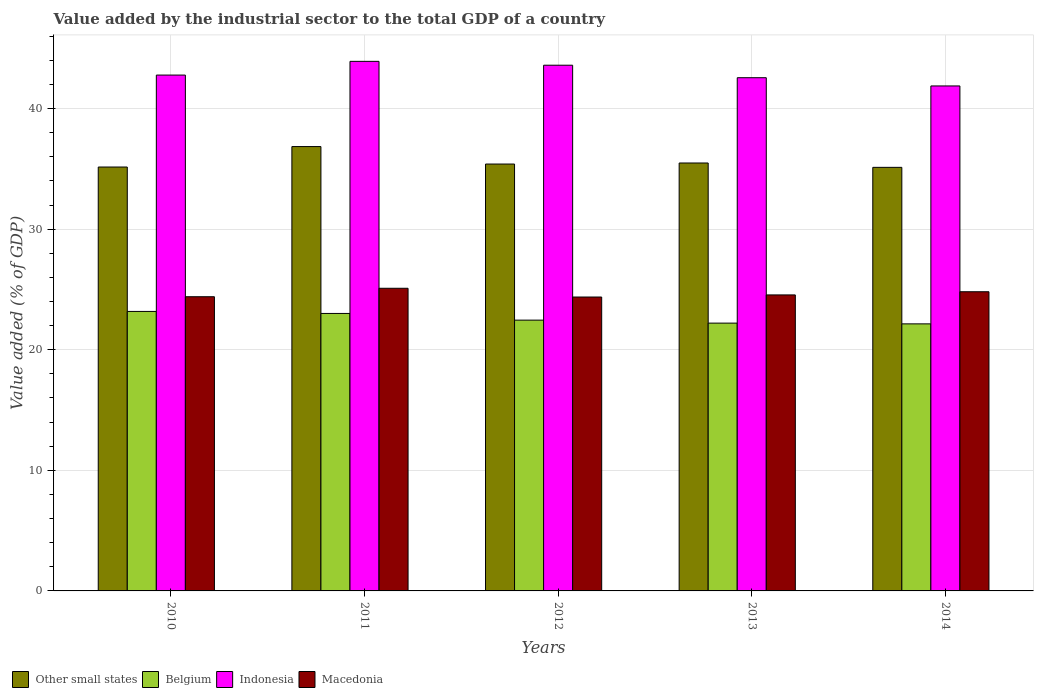How many groups of bars are there?
Offer a very short reply. 5. Are the number of bars per tick equal to the number of legend labels?
Offer a very short reply. Yes. How many bars are there on the 4th tick from the right?
Your response must be concise. 4. What is the value added by the industrial sector to the total GDP in Other small states in 2013?
Provide a short and direct response. 35.49. Across all years, what is the maximum value added by the industrial sector to the total GDP in Indonesia?
Give a very brief answer. 43.91. Across all years, what is the minimum value added by the industrial sector to the total GDP in Indonesia?
Keep it short and to the point. 41.87. What is the total value added by the industrial sector to the total GDP in Macedonia in the graph?
Your answer should be very brief. 123.22. What is the difference between the value added by the industrial sector to the total GDP in Macedonia in 2012 and that in 2013?
Offer a terse response. -0.17. What is the difference between the value added by the industrial sector to the total GDP in Other small states in 2011 and the value added by the industrial sector to the total GDP in Belgium in 2014?
Give a very brief answer. 14.7. What is the average value added by the industrial sector to the total GDP in Other small states per year?
Provide a succinct answer. 35.6. In the year 2013, what is the difference between the value added by the industrial sector to the total GDP in Macedonia and value added by the industrial sector to the total GDP in Indonesia?
Ensure brevity in your answer.  -18.01. What is the ratio of the value added by the industrial sector to the total GDP in Other small states in 2012 to that in 2014?
Your answer should be compact. 1.01. What is the difference between the highest and the second highest value added by the industrial sector to the total GDP in Other small states?
Keep it short and to the point. 1.36. What is the difference between the highest and the lowest value added by the industrial sector to the total GDP in Macedonia?
Offer a terse response. 0.72. Is it the case that in every year, the sum of the value added by the industrial sector to the total GDP in Indonesia and value added by the industrial sector to the total GDP in Other small states is greater than the sum of value added by the industrial sector to the total GDP in Belgium and value added by the industrial sector to the total GDP in Macedonia?
Make the answer very short. No. What does the 4th bar from the left in 2011 represents?
Provide a short and direct response. Macedonia. Is it the case that in every year, the sum of the value added by the industrial sector to the total GDP in Belgium and value added by the industrial sector to the total GDP in Macedonia is greater than the value added by the industrial sector to the total GDP in Other small states?
Your response must be concise. Yes. Are the values on the major ticks of Y-axis written in scientific E-notation?
Your answer should be very brief. No. Does the graph contain any zero values?
Give a very brief answer. No. Does the graph contain grids?
Offer a very short reply. Yes. Where does the legend appear in the graph?
Keep it short and to the point. Bottom left. How many legend labels are there?
Give a very brief answer. 4. What is the title of the graph?
Your answer should be very brief. Value added by the industrial sector to the total GDP of a country. Does "Mauritius" appear as one of the legend labels in the graph?
Keep it short and to the point. No. What is the label or title of the Y-axis?
Your answer should be very brief. Value added (% of GDP). What is the Value added (% of GDP) in Other small states in 2010?
Ensure brevity in your answer.  35.15. What is the Value added (% of GDP) in Belgium in 2010?
Provide a short and direct response. 23.18. What is the Value added (% of GDP) in Indonesia in 2010?
Your response must be concise. 42.78. What is the Value added (% of GDP) of Macedonia in 2010?
Provide a succinct answer. 24.4. What is the Value added (% of GDP) of Other small states in 2011?
Your response must be concise. 36.85. What is the Value added (% of GDP) of Belgium in 2011?
Offer a terse response. 23.01. What is the Value added (% of GDP) of Indonesia in 2011?
Your answer should be compact. 43.91. What is the Value added (% of GDP) of Macedonia in 2011?
Give a very brief answer. 25.1. What is the Value added (% of GDP) in Other small states in 2012?
Ensure brevity in your answer.  35.4. What is the Value added (% of GDP) in Belgium in 2012?
Keep it short and to the point. 22.45. What is the Value added (% of GDP) in Indonesia in 2012?
Your response must be concise. 43.59. What is the Value added (% of GDP) of Macedonia in 2012?
Your response must be concise. 24.37. What is the Value added (% of GDP) of Other small states in 2013?
Keep it short and to the point. 35.49. What is the Value added (% of GDP) in Belgium in 2013?
Your response must be concise. 22.21. What is the Value added (% of GDP) of Indonesia in 2013?
Make the answer very short. 42.56. What is the Value added (% of GDP) of Macedonia in 2013?
Make the answer very short. 24.55. What is the Value added (% of GDP) in Other small states in 2014?
Offer a very short reply. 35.12. What is the Value added (% of GDP) in Belgium in 2014?
Your answer should be very brief. 22.15. What is the Value added (% of GDP) in Indonesia in 2014?
Your answer should be compact. 41.87. What is the Value added (% of GDP) in Macedonia in 2014?
Provide a succinct answer. 24.81. Across all years, what is the maximum Value added (% of GDP) in Other small states?
Make the answer very short. 36.85. Across all years, what is the maximum Value added (% of GDP) in Belgium?
Offer a terse response. 23.18. Across all years, what is the maximum Value added (% of GDP) of Indonesia?
Provide a short and direct response. 43.91. Across all years, what is the maximum Value added (% of GDP) in Macedonia?
Ensure brevity in your answer.  25.1. Across all years, what is the minimum Value added (% of GDP) of Other small states?
Your answer should be very brief. 35.12. Across all years, what is the minimum Value added (% of GDP) in Belgium?
Keep it short and to the point. 22.15. Across all years, what is the minimum Value added (% of GDP) of Indonesia?
Your answer should be very brief. 41.87. Across all years, what is the minimum Value added (% of GDP) in Macedonia?
Provide a succinct answer. 24.37. What is the total Value added (% of GDP) in Other small states in the graph?
Offer a very short reply. 178.01. What is the total Value added (% of GDP) in Belgium in the graph?
Provide a short and direct response. 112.99. What is the total Value added (% of GDP) of Indonesia in the graph?
Make the answer very short. 214.71. What is the total Value added (% of GDP) of Macedonia in the graph?
Make the answer very short. 123.22. What is the difference between the Value added (% of GDP) in Other small states in 2010 and that in 2011?
Provide a succinct answer. -1.7. What is the difference between the Value added (% of GDP) in Belgium in 2010 and that in 2011?
Your answer should be compact. 0.17. What is the difference between the Value added (% of GDP) in Indonesia in 2010 and that in 2011?
Your answer should be compact. -1.14. What is the difference between the Value added (% of GDP) in Macedonia in 2010 and that in 2011?
Keep it short and to the point. -0.7. What is the difference between the Value added (% of GDP) of Other small states in 2010 and that in 2012?
Your answer should be very brief. -0.25. What is the difference between the Value added (% of GDP) in Belgium in 2010 and that in 2012?
Ensure brevity in your answer.  0.72. What is the difference between the Value added (% of GDP) of Indonesia in 2010 and that in 2012?
Your answer should be compact. -0.82. What is the difference between the Value added (% of GDP) in Macedonia in 2010 and that in 2012?
Provide a short and direct response. 0.02. What is the difference between the Value added (% of GDP) of Other small states in 2010 and that in 2013?
Ensure brevity in your answer.  -0.33. What is the difference between the Value added (% of GDP) in Belgium in 2010 and that in 2013?
Provide a succinct answer. 0.97. What is the difference between the Value added (% of GDP) of Indonesia in 2010 and that in 2013?
Your response must be concise. 0.22. What is the difference between the Value added (% of GDP) of Macedonia in 2010 and that in 2013?
Provide a short and direct response. -0.15. What is the difference between the Value added (% of GDP) in Other small states in 2010 and that in 2014?
Ensure brevity in your answer.  0.03. What is the difference between the Value added (% of GDP) in Belgium in 2010 and that in 2014?
Give a very brief answer. 1.03. What is the difference between the Value added (% of GDP) in Indonesia in 2010 and that in 2014?
Your answer should be very brief. 0.9. What is the difference between the Value added (% of GDP) of Macedonia in 2010 and that in 2014?
Offer a very short reply. -0.41. What is the difference between the Value added (% of GDP) of Other small states in 2011 and that in 2012?
Your answer should be very brief. 1.45. What is the difference between the Value added (% of GDP) in Belgium in 2011 and that in 2012?
Ensure brevity in your answer.  0.55. What is the difference between the Value added (% of GDP) of Indonesia in 2011 and that in 2012?
Provide a short and direct response. 0.32. What is the difference between the Value added (% of GDP) of Macedonia in 2011 and that in 2012?
Keep it short and to the point. 0.72. What is the difference between the Value added (% of GDP) of Other small states in 2011 and that in 2013?
Provide a short and direct response. 1.36. What is the difference between the Value added (% of GDP) of Belgium in 2011 and that in 2013?
Your answer should be compact. 0.8. What is the difference between the Value added (% of GDP) in Indonesia in 2011 and that in 2013?
Your answer should be very brief. 1.36. What is the difference between the Value added (% of GDP) in Macedonia in 2011 and that in 2013?
Make the answer very short. 0.55. What is the difference between the Value added (% of GDP) of Other small states in 2011 and that in 2014?
Your answer should be compact. 1.72. What is the difference between the Value added (% of GDP) of Belgium in 2011 and that in 2014?
Your response must be concise. 0.86. What is the difference between the Value added (% of GDP) in Indonesia in 2011 and that in 2014?
Offer a very short reply. 2.04. What is the difference between the Value added (% of GDP) of Macedonia in 2011 and that in 2014?
Provide a succinct answer. 0.29. What is the difference between the Value added (% of GDP) in Other small states in 2012 and that in 2013?
Offer a terse response. -0.09. What is the difference between the Value added (% of GDP) in Belgium in 2012 and that in 2013?
Your answer should be very brief. 0.25. What is the difference between the Value added (% of GDP) of Indonesia in 2012 and that in 2013?
Keep it short and to the point. 1.04. What is the difference between the Value added (% of GDP) of Macedonia in 2012 and that in 2013?
Offer a terse response. -0.17. What is the difference between the Value added (% of GDP) in Other small states in 2012 and that in 2014?
Keep it short and to the point. 0.27. What is the difference between the Value added (% of GDP) in Belgium in 2012 and that in 2014?
Ensure brevity in your answer.  0.31. What is the difference between the Value added (% of GDP) of Indonesia in 2012 and that in 2014?
Provide a succinct answer. 1.72. What is the difference between the Value added (% of GDP) of Macedonia in 2012 and that in 2014?
Provide a succinct answer. -0.44. What is the difference between the Value added (% of GDP) in Other small states in 2013 and that in 2014?
Your answer should be compact. 0.36. What is the difference between the Value added (% of GDP) in Belgium in 2013 and that in 2014?
Offer a very short reply. 0.06. What is the difference between the Value added (% of GDP) of Indonesia in 2013 and that in 2014?
Offer a terse response. 0.68. What is the difference between the Value added (% of GDP) in Macedonia in 2013 and that in 2014?
Give a very brief answer. -0.26. What is the difference between the Value added (% of GDP) in Other small states in 2010 and the Value added (% of GDP) in Belgium in 2011?
Provide a succinct answer. 12.14. What is the difference between the Value added (% of GDP) in Other small states in 2010 and the Value added (% of GDP) in Indonesia in 2011?
Make the answer very short. -8.76. What is the difference between the Value added (% of GDP) of Other small states in 2010 and the Value added (% of GDP) of Macedonia in 2011?
Make the answer very short. 10.05. What is the difference between the Value added (% of GDP) of Belgium in 2010 and the Value added (% of GDP) of Indonesia in 2011?
Give a very brief answer. -20.74. What is the difference between the Value added (% of GDP) in Belgium in 2010 and the Value added (% of GDP) in Macedonia in 2011?
Your answer should be very brief. -1.92. What is the difference between the Value added (% of GDP) in Indonesia in 2010 and the Value added (% of GDP) in Macedonia in 2011?
Keep it short and to the point. 17.68. What is the difference between the Value added (% of GDP) in Other small states in 2010 and the Value added (% of GDP) in Belgium in 2012?
Give a very brief answer. 12.7. What is the difference between the Value added (% of GDP) of Other small states in 2010 and the Value added (% of GDP) of Indonesia in 2012?
Provide a short and direct response. -8.44. What is the difference between the Value added (% of GDP) in Other small states in 2010 and the Value added (% of GDP) in Macedonia in 2012?
Your response must be concise. 10.78. What is the difference between the Value added (% of GDP) in Belgium in 2010 and the Value added (% of GDP) in Indonesia in 2012?
Provide a short and direct response. -20.42. What is the difference between the Value added (% of GDP) of Belgium in 2010 and the Value added (% of GDP) of Macedonia in 2012?
Ensure brevity in your answer.  -1.2. What is the difference between the Value added (% of GDP) in Indonesia in 2010 and the Value added (% of GDP) in Macedonia in 2012?
Keep it short and to the point. 18.4. What is the difference between the Value added (% of GDP) in Other small states in 2010 and the Value added (% of GDP) in Belgium in 2013?
Your response must be concise. 12.94. What is the difference between the Value added (% of GDP) in Other small states in 2010 and the Value added (% of GDP) in Indonesia in 2013?
Give a very brief answer. -7.41. What is the difference between the Value added (% of GDP) of Other small states in 2010 and the Value added (% of GDP) of Macedonia in 2013?
Make the answer very short. 10.61. What is the difference between the Value added (% of GDP) of Belgium in 2010 and the Value added (% of GDP) of Indonesia in 2013?
Offer a very short reply. -19.38. What is the difference between the Value added (% of GDP) in Belgium in 2010 and the Value added (% of GDP) in Macedonia in 2013?
Offer a terse response. -1.37. What is the difference between the Value added (% of GDP) of Indonesia in 2010 and the Value added (% of GDP) of Macedonia in 2013?
Ensure brevity in your answer.  18.23. What is the difference between the Value added (% of GDP) in Other small states in 2010 and the Value added (% of GDP) in Belgium in 2014?
Ensure brevity in your answer.  13.01. What is the difference between the Value added (% of GDP) in Other small states in 2010 and the Value added (% of GDP) in Indonesia in 2014?
Offer a terse response. -6.72. What is the difference between the Value added (% of GDP) of Other small states in 2010 and the Value added (% of GDP) of Macedonia in 2014?
Ensure brevity in your answer.  10.34. What is the difference between the Value added (% of GDP) in Belgium in 2010 and the Value added (% of GDP) in Indonesia in 2014?
Make the answer very short. -18.7. What is the difference between the Value added (% of GDP) in Belgium in 2010 and the Value added (% of GDP) in Macedonia in 2014?
Your answer should be very brief. -1.63. What is the difference between the Value added (% of GDP) of Indonesia in 2010 and the Value added (% of GDP) of Macedonia in 2014?
Your answer should be very brief. 17.97. What is the difference between the Value added (% of GDP) in Other small states in 2011 and the Value added (% of GDP) in Belgium in 2012?
Offer a terse response. 14.39. What is the difference between the Value added (% of GDP) of Other small states in 2011 and the Value added (% of GDP) of Indonesia in 2012?
Your answer should be very brief. -6.75. What is the difference between the Value added (% of GDP) of Other small states in 2011 and the Value added (% of GDP) of Macedonia in 2012?
Offer a terse response. 12.47. What is the difference between the Value added (% of GDP) in Belgium in 2011 and the Value added (% of GDP) in Indonesia in 2012?
Your answer should be compact. -20.58. What is the difference between the Value added (% of GDP) of Belgium in 2011 and the Value added (% of GDP) of Macedonia in 2012?
Ensure brevity in your answer.  -1.36. What is the difference between the Value added (% of GDP) in Indonesia in 2011 and the Value added (% of GDP) in Macedonia in 2012?
Provide a succinct answer. 19.54. What is the difference between the Value added (% of GDP) of Other small states in 2011 and the Value added (% of GDP) of Belgium in 2013?
Your answer should be very brief. 14.64. What is the difference between the Value added (% of GDP) of Other small states in 2011 and the Value added (% of GDP) of Indonesia in 2013?
Offer a terse response. -5.71. What is the difference between the Value added (% of GDP) in Other small states in 2011 and the Value added (% of GDP) in Macedonia in 2013?
Your answer should be very brief. 12.3. What is the difference between the Value added (% of GDP) of Belgium in 2011 and the Value added (% of GDP) of Indonesia in 2013?
Ensure brevity in your answer.  -19.55. What is the difference between the Value added (% of GDP) of Belgium in 2011 and the Value added (% of GDP) of Macedonia in 2013?
Provide a short and direct response. -1.54. What is the difference between the Value added (% of GDP) of Indonesia in 2011 and the Value added (% of GDP) of Macedonia in 2013?
Make the answer very short. 19.37. What is the difference between the Value added (% of GDP) of Other small states in 2011 and the Value added (% of GDP) of Belgium in 2014?
Your answer should be very brief. 14.7. What is the difference between the Value added (% of GDP) in Other small states in 2011 and the Value added (% of GDP) in Indonesia in 2014?
Offer a terse response. -5.03. What is the difference between the Value added (% of GDP) of Other small states in 2011 and the Value added (% of GDP) of Macedonia in 2014?
Keep it short and to the point. 12.04. What is the difference between the Value added (% of GDP) of Belgium in 2011 and the Value added (% of GDP) of Indonesia in 2014?
Offer a terse response. -18.86. What is the difference between the Value added (% of GDP) of Belgium in 2011 and the Value added (% of GDP) of Macedonia in 2014?
Offer a very short reply. -1.8. What is the difference between the Value added (% of GDP) in Indonesia in 2011 and the Value added (% of GDP) in Macedonia in 2014?
Your answer should be very brief. 19.1. What is the difference between the Value added (% of GDP) in Other small states in 2012 and the Value added (% of GDP) in Belgium in 2013?
Provide a short and direct response. 13.19. What is the difference between the Value added (% of GDP) of Other small states in 2012 and the Value added (% of GDP) of Indonesia in 2013?
Offer a terse response. -7.16. What is the difference between the Value added (% of GDP) of Other small states in 2012 and the Value added (% of GDP) of Macedonia in 2013?
Make the answer very short. 10.85. What is the difference between the Value added (% of GDP) in Belgium in 2012 and the Value added (% of GDP) in Indonesia in 2013?
Provide a succinct answer. -20.1. What is the difference between the Value added (% of GDP) in Belgium in 2012 and the Value added (% of GDP) in Macedonia in 2013?
Offer a terse response. -2.09. What is the difference between the Value added (% of GDP) in Indonesia in 2012 and the Value added (% of GDP) in Macedonia in 2013?
Make the answer very short. 19.05. What is the difference between the Value added (% of GDP) of Other small states in 2012 and the Value added (% of GDP) of Belgium in 2014?
Keep it short and to the point. 13.25. What is the difference between the Value added (% of GDP) of Other small states in 2012 and the Value added (% of GDP) of Indonesia in 2014?
Ensure brevity in your answer.  -6.48. What is the difference between the Value added (% of GDP) of Other small states in 2012 and the Value added (% of GDP) of Macedonia in 2014?
Keep it short and to the point. 10.59. What is the difference between the Value added (% of GDP) in Belgium in 2012 and the Value added (% of GDP) in Indonesia in 2014?
Provide a short and direct response. -19.42. What is the difference between the Value added (% of GDP) in Belgium in 2012 and the Value added (% of GDP) in Macedonia in 2014?
Your response must be concise. -2.35. What is the difference between the Value added (% of GDP) in Indonesia in 2012 and the Value added (% of GDP) in Macedonia in 2014?
Provide a short and direct response. 18.79. What is the difference between the Value added (% of GDP) in Other small states in 2013 and the Value added (% of GDP) in Belgium in 2014?
Offer a terse response. 13.34. What is the difference between the Value added (% of GDP) in Other small states in 2013 and the Value added (% of GDP) in Indonesia in 2014?
Ensure brevity in your answer.  -6.39. What is the difference between the Value added (% of GDP) of Other small states in 2013 and the Value added (% of GDP) of Macedonia in 2014?
Make the answer very short. 10.68. What is the difference between the Value added (% of GDP) of Belgium in 2013 and the Value added (% of GDP) of Indonesia in 2014?
Ensure brevity in your answer.  -19.67. What is the difference between the Value added (% of GDP) of Belgium in 2013 and the Value added (% of GDP) of Macedonia in 2014?
Make the answer very short. -2.6. What is the difference between the Value added (% of GDP) in Indonesia in 2013 and the Value added (% of GDP) in Macedonia in 2014?
Give a very brief answer. 17.75. What is the average Value added (% of GDP) in Other small states per year?
Offer a very short reply. 35.6. What is the average Value added (% of GDP) in Belgium per year?
Your answer should be very brief. 22.6. What is the average Value added (% of GDP) of Indonesia per year?
Your answer should be very brief. 42.94. What is the average Value added (% of GDP) in Macedonia per year?
Keep it short and to the point. 24.64. In the year 2010, what is the difference between the Value added (% of GDP) of Other small states and Value added (% of GDP) of Belgium?
Your response must be concise. 11.97. In the year 2010, what is the difference between the Value added (% of GDP) of Other small states and Value added (% of GDP) of Indonesia?
Make the answer very short. -7.63. In the year 2010, what is the difference between the Value added (% of GDP) of Other small states and Value added (% of GDP) of Macedonia?
Provide a short and direct response. 10.76. In the year 2010, what is the difference between the Value added (% of GDP) in Belgium and Value added (% of GDP) in Indonesia?
Offer a terse response. -19.6. In the year 2010, what is the difference between the Value added (% of GDP) of Belgium and Value added (% of GDP) of Macedonia?
Ensure brevity in your answer.  -1.22. In the year 2010, what is the difference between the Value added (% of GDP) in Indonesia and Value added (% of GDP) in Macedonia?
Offer a very short reply. 18.38. In the year 2011, what is the difference between the Value added (% of GDP) of Other small states and Value added (% of GDP) of Belgium?
Provide a short and direct response. 13.84. In the year 2011, what is the difference between the Value added (% of GDP) in Other small states and Value added (% of GDP) in Indonesia?
Provide a succinct answer. -7.07. In the year 2011, what is the difference between the Value added (% of GDP) of Other small states and Value added (% of GDP) of Macedonia?
Your response must be concise. 11.75. In the year 2011, what is the difference between the Value added (% of GDP) of Belgium and Value added (% of GDP) of Indonesia?
Your answer should be compact. -20.9. In the year 2011, what is the difference between the Value added (% of GDP) in Belgium and Value added (% of GDP) in Macedonia?
Offer a terse response. -2.09. In the year 2011, what is the difference between the Value added (% of GDP) of Indonesia and Value added (% of GDP) of Macedonia?
Provide a short and direct response. 18.82. In the year 2012, what is the difference between the Value added (% of GDP) of Other small states and Value added (% of GDP) of Belgium?
Give a very brief answer. 12.94. In the year 2012, what is the difference between the Value added (% of GDP) in Other small states and Value added (% of GDP) in Indonesia?
Your answer should be compact. -8.2. In the year 2012, what is the difference between the Value added (% of GDP) of Other small states and Value added (% of GDP) of Macedonia?
Provide a succinct answer. 11.03. In the year 2012, what is the difference between the Value added (% of GDP) in Belgium and Value added (% of GDP) in Indonesia?
Provide a succinct answer. -21.14. In the year 2012, what is the difference between the Value added (% of GDP) of Belgium and Value added (% of GDP) of Macedonia?
Provide a succinct answer. -1.92. In the year 2012, what is the difference between the Value added (% of GDP) of Indonesia and Value added (% of GDP) of Macedonia?
Your response must be concise. 19.22. In the year 2013, what is the difference between the Value added (% of GDP) of Other small states and Value added (% of GDP) of Belgium?
Keep it short and to the point. 13.28. In the year 2013, what is the difference between the Value added (% of GDP) of Other small states and Value added (% of GDP) of Indonesia?
Your answer should be compact. -7.07. In the year 2013, what is the difference between the Value added (% of GDP) in Other small states and Value added (% of GDP) in Macedonia?
Make the answer very short. 10.94. In the year 2013, what is the difference between the Value added (% of GDP) in Belgium and Value added (% of GDP) in Indonesia?
Your answer should be compact. -20.35. In the year 2013, what is the difference between the Value added (% of GDP) of Belgium and Value added (% of GDP) of Macedonia?
Give a very brief answer. -2.34. In the year 2013, what is the difference between the Value added (% of GDP) of Indonesia and Value added (% of GDP) of Macedonia?
Provide a short and direct response. 18.01. In the year 2014, what is the difference between the Value added (% of GDP) of Other small states and Value added (% of GDP) of Belgium?
Provide a succinct answer. 12.98. In the year 2014, what is the difference between the Value added (% of GDP) in Other small states and Value added (% of GDP) in Indonesia?
Give a very brief answer. -6.75. In the year 2014, what is the difference between the Value added (% of GDP) of Other small states and Value added (% of GDP) of Macedonia?
Provide a short and direct response. 10.32. In the year 2014, what is the difference between the Value added (% of GDP) of Belgium and Value added (% of GDP) of Indonesia?
Offer a terse response. -19.73. In the year 2014, what is the difference between the Value added (% of GDP) of Belgium and Value added (% of GDP) of Macedonia?
Provide a short and direct response. -2.66. In the year 2014, what is the difference between the Value added (% of GDP) in Indonesia and Value added (% of GDP) in Macedonia?
Provide a succinct answer. 17.07. What is the ratio of the Value added (% of GDP) in Other small states in 2010 to that in 2011?
Your answer should be compact. 0.95. What is the ratio of the Value added (% of GDP) in Belgium in 2010 to that in 2011?
Give a very brief answer. 1.01. What is the ratio of the Value added (% of GDP) of Indonesia in 2010 to that in 2011?
Keep it short and to the point. 0.97. What is the ratio of the Value added (% of GDP) of Macedonia in 2010 to that in 2011?
Offer a terse response. 0.97. What is the ratio of the Value added (% of GDP) of Other small states in 2010 to that in 2012?
Provide a succinct answer. 0.99. What is the ratio of the Value added (% of GDP) in Belgium in 2010 to that in 2012?
Offer a terse response. 1.03. What is the ratio of the Value added (% of GDP) in Indonesia in 2010 to that in 2012?
Offer a terse response. 0.98. What is the ratio of the Value added (% of GDP) in Other small states in 2010 to that in 2013?
Your answer should be compact. 0.99. What is the ratio of the Value added (% of GDP) of Belgium in 2010 to that in 2013?
Provide a short and direct response. 1.04. What is the ratio of the Value added (% of GDP) in Indonesia in 2010 to that in 2013?
Make the answer very short. 1.01. What is the ratio of the Value added (% of GDP) in Belgium in 2010 to that in 2014?
Provide a short and direct response. 1.05. What is the ratio of the Value added (% of GDP) of Indonesia in 2010 to that in 2014?
Provide a succinct answer. 1.02. What is the ratio of the Value added (% of GDP) in Macedonia in 2010 to that in 2014?
Offer a terse response. 0.98. What is the ratio of the Value added (% of GDP) of Other small states in 2011 to that in 2012?
Give a very brief answer. 1.04. What is the ratio of the Value added (% of GDP) of Belgium in 2011 to that in 2012?
Offer a terse response. 1.02. What is the ratio of the Value added (% of GDP) of Indonesia in 2011 to that in 2012?
Your response must be concise. 1.01. What is the ratio of the Value added (% of GDP) in Macedonia in 2011 to that in 2012?
Give a very brief answer. 1.03. What is the ratio of the Value added (% of GDP) in Other small states in 2011 to that in 2013?
Provide a short and direct response. 1.04. What is the ratio of the Value added (% of GDP) in Belgium in 2011 to that in 2013?
Make the answer very short. 1.04. What is the ratio of the Value added (% of GDP) of Indonesia in 2011 to that in 2013?
Give a very brief answer. 1.03. What is the ratio of the Value added (% of GDP) in Macedonia in 2011 to that in 2013?
Provide a succinct answer. 1.02. What is the ratio of the Value added (% of GDP) of Other small states in 2011 to that in 2014?
Make the answer very short. 1.05. What is the ratio of the Value added (% of GDP) in Belgium in 2011 to that in 2014?
Offer a terse response. 1.04. What is the ratio of the Value added (% of GDP) in Indonesia in 2011 to that in 2014?
Ensure brevity in your answer.  1.05. What is the ratio of the Value added (% of GDP) in Macedonia in 2011 to that in 2014?
Ensure brevity in your answer.  1.01. What is the ratio of the Value added (% of GDP) of Belgium in 2012 to that in 2013?
Provide a succinct answer. 1.01. What is the ratio of the Value added (% of GDP) of Indonesia in 2012 to that in 2013?
Your response must be concise. 1.02. What is the ratio of the Value added (% of GDP) in Macedonia in 2012 to that in 2013?
Your answer should be compact. 0.99. What is the ratio of the Value added (% of GDP) in Other small states in 2012 to that in 2014?
Ensure brevity in your answer.  1.01. What is the ratio of the Value added (% of GDP) in Belgium in 2012 to that in 2014?
Provide a short and direct response. 1.01. What is the ratio of the Value added (% of GDP) in Indonesia in 2012 to that in 2014?
Offer a very short reply. 1.04. What is the ratio of the Value added (% of GDP) in Macedonia in 2012 to that in 2014?
Offer a terse response. 0.98. What is the ratio of the Value added (% of GDP) of Other small states in 2013 to that in 2014?
Give a very brief answer. 1.01. What is the ratio of the Value added (% of GDP) of Belgium in 2013 to that in 2014?
Offer a very short reply. 1. What is the ratio of the Value added (% of GDP) in Indonesia in 2013 to that in 2014?
Ensure brevity in your answer.  1.02. What is the difference between the highest and the second highest Value added (% of GDP) in Other small states?
Offer a very short reply. 1.36. What is the difference between the highest and the second highest Value added (% of GDP) in Belgium?
Keep it short and to the point. 0.17. What is the difference between the highest and the second highest Value added (% of GDP) of Indonesia?
Give a very brief answer. 0.32. What is the difference between the highest and the second highest Value added (% of GDP) in Macedonia?
Your answer should be compact. 0.29. What is the difference between the highest and the lowest Value added (% of GDP) in Other small states?
Provide a short and direct response. 1.72. What is the difference between the highest and the lowest Value added (% of GDP) of Belgium?
Give a very brief answer. 1.03. What is the difference between the highest and the lowest Value added (% of GDP) in Indonesia?
Provide a short and direct response. 2.04. What is the difference between the highest and the lowest Value added (% of GDP) of Macedonia?
Your response must be concise. 0.72. 